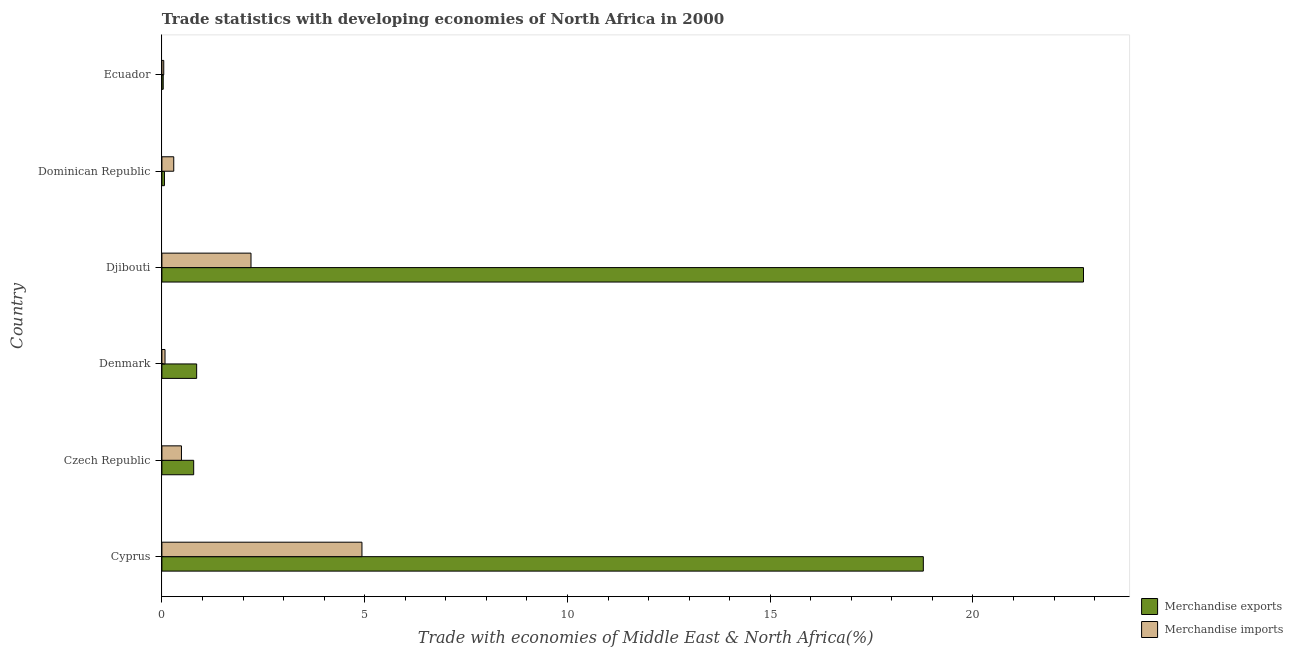How many different coloured bars are there?
Your answer should be compact. 2. How many groups of bars are there?
Provide a short and direct response. 6. How many bars are there on the 4th tick from the top?
Ensure brevity in your answer.  2. What is the label of the 5th group of bars from the top?
Offer a terse response. Czech Republic. What is the merchandise imports in Djibouti?
Give a very brief answer. 2.2. Across all countries, what is the maximum merchandise imports?
Your answer should be very brief. 4.93. Across all countries, what is the minimum merchandise imports?
Your answer should be compact. 0.05. In which country was the merchandise imports maximum?
Provide a succinct answer. Cyprus. In which country was the merchandise exports minimum?
Your response must be concise. Ecuador. What is the total merchandise imports in the graph?
Your answer should be compact. 8.03. What is the difference between the merchandise imports in Czech Republic and that in Dominican Republic?
Provide a succinct answer. 0.19. What is the difference between the merchandise imports in Cyprus and the merchandise exports in Djibouti?
Your answer should be very brief. -17.79. What is the average merchandise exports per country?
Keep it short and to the point. 7.21. What is the difference between the merchandise exports and merchandise imports in Dominican Republic?
Your answer should be compact. -0.23. In how many countries, is the merchandise imports greater than 13 %?
Offer a terse response. 0. What is the ratio of the merchandise imports in Djibouti to that in Dominican Republic?
Provide a succinct answer. 7.52. Is the merchandise exports in Denmark less than that in Djibouti?
Your answer should be compact. Yes. Is the difference between the merchandise exports in Czech Republic and Dominican Republic greater than the difference between the merchandise imports in Czech Republic and Dominican Republic?
Make the answer very short. Yes. What is the difference between the highest and the second highest merchandise exports?
Offer a terse response. 3.95. What is the difference between the highest and the lowest merchandise imports?
Give a very brief answer. 4.89. What does the 2nd bar from the bottom in Denmark represents?
Offer a very short reply. Merchandise imports. How many countries are there in the graph?
Your answer should be compact. 6. Are the values on the major ticks of X-axis written in scientific E-notation?
Offer a very short reply. No. How are the legend labels stacked?
Give a very brief answer. Vertical. What is the title of the graph?
Offer a very short reply. Trade statistics with developing economies of North Africa in 2000. What is the label or title of the X-axis?
Ensure brevity in your answer.  Trade with economies of Middle East & North Africa(%). What is the Trade with economies of Middle East & North Africa(%) of Merchandise exports in Cyprus?
Your answer should be compact. 18.78. What is the Trade with economies of Middle East & North Africa(%) in Merchandise imports in Cyprus?
Give a very brief answer. 4.93. What is the Trade with economies of Middle East & North Africa(%) of Merchandise exports in Czech Republic?
Ensure brevity in your answer.  0.78. What is the Trade with economies of Middle East & North Africa(%) in Merchandise imports in Czech Republic?
Your answer should be very brief. 0.48. What is the Trade with economies of Middle East & North Africa(%) of Merchandise exports in Denmark?
Keep it short and to the point. 0.86. What is the Trade with economies of Middle East & North Africa(%) of Merchandise imports in Denmark?
Provide a succinct answer. 0.08. What is the Trade with economies of Middle East & North Africa(%) of Merchandise exports in Djibouti?
Your answer should be very brief. 22.73. What is the Trade with economies of Middle East & North Africa(%) in Merchandise imports in Djibouti?
Offer a very short reply. 2.2. What is the Trade with economies of Middle East & North Africa(%) in Merchandise exports in Dominican Republic?
Ensure brevity in your answer.  0.06. What is the Trade with economies of Middle East & North Africa(%) in Merchandise imports in Dominican Republic?
Ensure brevity in your answer.  0.29. What is the Trade with economies of Middle East & North Africa(%) in Merchandise exports in Ecuador?
Give a very brief answer. 0.03. What is the Trade with economies of Middle East & North Africa(%) in Merchandise imports in Ecuador?
Provide a succinct answer. 0.05. Across all countries, what is the maximum Trade with economies of Middle East & North Africa(%) of Merchandise exports?
Your answer should be compact. 22.73. Across all countries, what is the maximum Trade with economies of Middle East & North Africa(%) in Merchandise imports?
Your answer should be compact. 4.93. Across all countries, what is the minimum Trade with economies of Middle East & North Africa(%) of Merchandise exports?
Offer a terse response. 0.03. Across all countries, what is the minimum Trade with economies of Middle East & North Africa(%) of Merchandise imports?
Provide a succinct answer. 0.05. What is the total Trade with economies of Middle East & North Africa(%) of Merchandise exports in the graph?
Offer a terse response. 43.24. What is the total Trade with economies of Middle East & North Africa(%) of Merchandise imports in the graph?
Your answer should be very brief. 8.03. What is the difference between the Trade with economies of Middle East & North Africa(%) of Merchandise exports in Cyprus and that in Czech Republic?
Your answer should be very brief. 17.99. What is the difference between the Trade with economies of Middle East & North Africa(%) in Merchandise imports in Cyprus and that in Czech Republic?
Your answer should be very brief. 4.45. What is the difference between the Trade with economies of Middle East & North Africa(%) of Merchandise exports in Cyprus and that in Denmark?
Keep it short and to the point. 17.92. What is the difference between the Trade with economies of Middle East & North Africa(%) in Merchandise imports in Cyprus and that in Denmark?
Provide a short and direct response. 4.86. What is the difference between the Trade with economies of Middle East & North Africa(%) of Merchandise exports in Cyprus and that in Djibouti?
Your answer should be compact. -3.95. What is the difference between the Trade with economies of Middle East & North Africa(%) in Merchandise imports in Cyprus and that in Djibouti?
Provide a short and direct response. 2.74. What is the difference between the Trade with economies of Middle East & North Africa(%) of Merchandise exports in Cyprus and that in Dominican Republic?
Keep it short and to the point. 18.71. What is the difference between the Trade with economies of Middle East & North Africa(%) in Merchandise imports in Cyprus and that in Dominican Republic?
Give a very brief answer. 4.64. What is the difference between the Trade with economies of Middle East & North Africa(%) of Merchandise exports in Cyprus and that in Ecuador?
Offer a very short reply. 18.74. What is the difference between the Trade with economies of Middle East & North Africa(%) in Merchandise imports in Cyprus and that in Ecuador?
Provide a short and direct response. 4.89. What is the difference between the Trade with economies of Middle East & North Africa(%) of Merchandise exports in Czech Republic and that in Denmark?
Provide a succinct answer. -0.07. What is the difference between the Trade with economies of Middle East & North Africa(%) of Merchandise imports in Czech Republic and that in Denmark?
Your response must be concise. 0.41. What is the difference between the Trade with economies of Middle East & North Africa(%) in Merchandise exports in Czech Republic and that in Djibouti?
Your answer should be compact. -21.94. What is the difference between the Trade with economies of Middle East & North Africa(%) of Merchandise imports in Czech Republic and that in Djibouti?
Your response must be concise. -1.71. What is the difference between the Trade with economies of Middle East & North Africa(%) in Merchandise exports in Czech Republic and that in Dominican Republic?
Provide a succinct answer. 0.72. What is the difference between the Trade with economies of Middle East & North Africa(%) in Merchandise imports in Czech Republic and that in Dominican Republic?
Your response must be concise. 0.19. What is the difference between the Trade with economies of Middle East & North Africa(%) of Merchandise exports in Czech Republic and that in Ecuador?
Provide a short and direct response. 0.75. What is the difference between the Trade with economies of Middle East & North Africa(%) of Merchandise imports in Czech Republic and that in Ecuador?
Provide a succinct answer. 0.44. What is the difference between the Trade with economies of Middle East & North Africa(%) in Merchandise exports in Denmark and that in Djibouti?
Offer a terse response. -21.87. What is the difference between the Trade with economies of Middle East & North Africa(%) in Merchandise imports in Denmark and that in Djibouti?
Provide a short and direct response. -2.12. What is the difference between the Trade with economies of Middle East & North Africa(%) of Merchandise exports in Denmark and that in Dominican Republic?
Provide a short and direct response. 0.79. What is the difference between the Trade with economies of Middle East & North Africa(%) in Merchandise imports in Denmark and that in Dominican Republic?
Your answer should be compact. -0.22. What is the difference between the Trade with economies of Middle East & North Africa(%) in Merchandise exports in Denmark and that in Ecuador?
Ensure brevity in your answer.  0.82. What is the difference between the Trade with economies of Middle East & North Africa(%) of Merchandise imports in Denmark and that in Ecuador?
Offer a very short reply. 0.03. What is the difference between the Trade with economies of Middle East & North Africa(%) of Merchandise exports in Djibouti and that in Dominican Republic?
Ensure brevity in your answer.  22.66. What is the difference between the Trade with economies of Middle East & North Africa(%) of Merchandise imports in Djibouti and that in Dominican Republic?
Provide a short and direct response. 1.9. What is the difference between the Trade with economies of Middle East & North Africa(%) in Merchandise exports in Djibouti and that in Ecuador?
Provide a succinct answer. 22.69. What is the difference between the Trade with economies of Middle East & North Africa(%) of Merchandise imports in Djibouti and that in Ecuador?
Provide a short and direct response. 2.15. What is the difference between the Trade with economies of Middle East & North Africa(%) in Merchandise exports in Dominican Republic and that in Ecuador?
Offer a terse response. 0.03. What is the difference between the Trade with economies of Middle East & North Africa(%) of Merchandise imports in Dominican Republic and that in Ecuador?
Keep it short and to the point. 0.25. What is the difference between the Trade with economies of Middle East & North Africa(%) in Merchandise exports in Cyprus and the Trade with economies of Middle East & North Africa(%) in Merchandise imports in Czech Republic?
Your answer should be very brief. 18.29. What is the difference between the Trade with economies of Middle East & North Africa(%) in Merchandise exports in Cyprus and the Trade with economies of Middle East & North Africa(%) in Merchandise imports in Denmark?
Provide a succinct answer. 18.7. What is the difference between the Trade with economies of Middle East & North Africa(%) of Merchandise exports in Cyprus and the Trade with economies of Middle East & North Africa(%) of Merchandise imports in Djibouti?
Your response must be concise. 16.58. What is the difference between the Trade with economies of Middle East & North Africa(%) in Merchandise exports in Cyprus and the Trade with economies of Middle East & North Africa(%) in Merchandise imports in Dominican Republic?
Keep it short and to the point. 18.48. What is the difference between the Trade with economies of Middle East & North Africa(%) of Merchandise exports in Cyprus and the Trade with economies of Middle East & North Africa(%) of Merchandise imports in Ecuador?
Your answer should be very brief. 18.73. What is the difference between the Trade with economies of Middle East & North Africa(%) in Merchandise exports in Czech Republic and the Trade with economies of Middle East & North Africa(%) in Merchandise imports in Denmark?
Make the answer very short. 0.71. What is the difference between the Trade with economies of Middle East & North Africa(%) in Merchandise exports in Czech Republic and the Trade with economies of Middle East & North Africa(%) in Merchandise imports in Djibouti?
Provide a short and direct response. -1.41. What is the difference between the Trade with economies of Middle East & North Africa(%) in Merchandise exports in Czech Republic and the Trade with economies of Middle East & North Africa(%) in Merchandise imports in Dominican Republic?
Give a very brief answer. 0.49. What is the difference between the Trade with economies of Middle East & North Africa(%) in Merchandise exports in Czech Republic and the Trade with economies of Middle East & North Africa(%) in Merchandise imports in Ecuador?
Offer a terse response. 0.74. What is the difference between the Trade with economies of Middle East & North Africa(%) in Merchandise exports in Denmark and the Trade with economies of Middle East & North Africa(%) in Merchandise imports in Djibouti?
Your response must be concise. -1.34. What is the difference between the Trade with economies of Middle East & North Africa(%) in Merchandise exports in Denmark and the Trade with economies of Middle East & North Africa(%) in Merchandise imports in Dominican Republic?
Your answer should be very brief. 0.57. What is the difference between the Trade with economies of Middle East & North Africa(%) in Merchandise exports in Denmark and the Trade with economies of Middle East & North Africa(%) in Merchandise imports in Ecuador?
Offer a very short reply. 0.81. What is the difference between the Trade with economies of Middle East & North Africa(%) of Merchandise exports in Djibouti and the Trade with economies of Middle East & North Africa(%) of Merchandise imports in Dominican Republic?
Offer a very short reply. 22.43. What is the difference between the Trade with economies of Middle East & North Africa(%) in Merchandise exports in Djibouti and the Trade with economies of Middle East & North Africa(%) in Merchandise imports in Ecuador?
Keep it short and to the point. 22.68. What is the difference between the Trade with economies of Middle East & North Africa(%) in Merchandise exports in Dominican Republic and the Trade with economies of Middle East & North Africa(%) in Merchandise imports in Ecuador?
Offer a very short reply. 0.02. What is the average Trade with economies of Middle East & North Africa(%) in Merchandise exports per country?
Provide a succinct answer. 7.21. What is the average Trade with economies of Middle East & North Africa(%) of Merchandise imports per country?
Make the answer very short. 1.34. What is the difference between the Trade with economies of Middle East & North Africa(%) of Merchandise exports and Trade with economies of Middle East & North Africa(%) of Merchandise imports in Cyprus?
Ensure brevity in your answer.  13.84. What is the difference between the Trade with economies of Middle East & North Africa(%) of Merchandise exports and Trade with economies of Middle East & North Africa(%) of Merchandise imports in Czech Republic?
Provide a short and direct response. 0.3. What is the difference between the Trade with economies of Middle East & North Africa(%) in Merchandise exports and Trade with economies of Middle East & North Africa(%) in Merchandise imports in Denmark?
Your answer should be very brief. 0.78. What is the difference between the Trade with economies of Middle East & North Africa(%) of Merchandise exports and Trade with economies of Middle East & North Africa(%) of Merchandise imports in Djibouti?
Your answer should be very brief. 20.53. What is the difference between the Trade with economies of Middle East & North Africa(%) in Merchandise exports and Trade with economies of Middle East & North Africa(%) in Merchandise imports in Dominican Republic?
Offer a very short reply. -0.23. What is the difference between the Trade with economies of Middle East & North Africa(%) of Merchandise exports and Trade with economies of Middle East & North Africa(%) of Merchandise imports in Ecuador?
Your answer should be very brief. -0.01. What is the ratio of the Trade with economies of Middle East & North Africa(%) in Merchandise exports in Cyprus to that in Czech Republic?
Offer a terse response. 23.96. What is the ratio of the Trade with economies of Middle East & North Africa(%) in Merchandise imports in Cyprus to that in Czech Republic?
Give a very brief answer. 10.23. What is the ratio of the Trade with economies of Middle East & North Africa(%) of Merchandise exports in Cyprus to that in Denmark?
Offer a terse response. 21.9. What is the ratio of the Trade with economies of Middle East & North Africa(%) in Merchandise imports in Cyprus to that in Denmark?
Ensure brevity in your answer.  64.27. What is the ratio of the Trade with economies of Middle East & North Africa(%) of Merchandise exports in Cyprus to that in Djibouti?
Offer a very short reply. 0.83. What is the ratio of the Trade with economies of Middle East & North Africa(%) of Merchandise imports in Cyprus to that in Djibouti?
Keep it short and to the point. 2.25. What is the ratio of the Trade with economies of Middle East & North Africa(%) of Merchandise exports in Cyprus to that in Dominican Republic?
Offer a terse response. 298.05. What is the ratio of the Trade with economies of Middle East & North Africa(%) in Merchandise imports in Cyprus to that in Dominican Republic?
Keep it short and to the point. 16.89. What is the ratio of the Trade with economies of Middle East & North Africa(%) in Merchandise exports in Cyprus to that in Ecuador?
Your response must be concise. 580.75. What is the ratio of the Trade with economies of Middle East & North Africa(%) in Merchandise imports in Cyprus to that in Ecuador?
Make the answer very short. 107.77. What is the ratio of the Trade with economies of Middle East & North Africa(%) of Merchandise exports in Czech Republic to that in Denmark?
Your response must be concise. 0.91. What is the ratio of the Trade with economies of Middle East & North Africa(%) of Merchandise imports in Czech Republic to that in Denmark?
Give a very brief answer. 6.28. What is the ratio of the Trade with economies of Middle East & North Africa(%) in Merchandise exports in Czech Republic to that in Djibouti?
Your response must be concise. 0.03. What is the ratio of the Trade with economies of Middle East & North Africa(%) of Merchandise imports in Czech Republic to that in Djibouti?
Offer a terse response. 0.22. What is the ratio of the Trade with economies of Middle East & North Africa(%) in Merchandise exports in Czech Republic to that in Dominican Republic?
Your answer should be very brief. 12.44. What is the ratio of the Trade with economies of Middle East & North Africa(%) of Merchandise imports in Czech Republic to that in Dominican Republic?
Make the answer very short. 1.65. What is the ratio of the Trade with economies of Middle East & North Africa(%) in Merchandise exports in Czech Republic to that in Ecuador?
Your answer should be very brief. 24.24. What is the ratio of the Trade with economies of Middle East & North Africa(%) of Merchandise imports in Czech Republic to that in Ecuador?
Offer a terse response. 10.54. What is the ratio of the Trade with economies of Middle East & North Africa(%) of Merchandise exports in Denmark to that in Djibouti?
Ensure brevity in your answer.  0.04. What is the ratio of the Trade with economies of Middle East & North Africa(%) in Merchandise imports in Denmark to that in Djibouti?
Keep it short and to the point. 0.03. What is the ratio of the Trade with economies of Middle East & North Africa(%) of Merchandise exports in Denmark to that in Dominican Republic?
Your answer should be compact. 13.61. What is the ratio of the Trade with economies of Middle East & North Africa(%) in Merchandise imports in Denmark to that in Dominican Republic?
Give a very brief answer. 0.26. What is the ratio of the Trade with economies of Middle East & North Africa(%) of Merchandise exports in Denmark to that in Ecuador?
Make the answer very short. 26.51. What is the ratio of the Trade with economies of Middle East & North Africa(%) in Merchandise imports in Denmark to that in Ecuador?
Offer a very short reply. 1.68. What is the ratio of the Trade with economies of Middle East & North Africa(%) of Merchandise exports in Djibouti to that in Dominican Republic?
Make the answer very short. 360.75. What is the ratio of the Trade with economies of Middle East & North Africa(%) in Merchandise imports in Djibouti to that in Dominican Republic?
Your response must be concise. 7.52. What is the ratio of the Trade with economies of Middle East & North Africa(%) in Merchandise exports in Djibouti to that in Ecuador?
Offer a terse response. 702.92. What is the ratio of the Trade with economies of Middle East & North Africa(%) of Merchandise imports in Djibouti to that in Ecuador?
Offer a terse response. 47.99. What is the ratio of the Trade with economies of Middle East & North Africa(%) in Merchandise exports in Dominican Republic to that in Ecuador?
Your answer should be compact. 1.95. What is the ratio of the Trade with economies of Middle East & North Africa(%) of Merchandise imports in Dominican Republic to that in Ecuador?
Provide a short and direct response. 6.38. What is the difference between the highest and the second highest Trade with economies of Middle East & North Africa(%) in Merchandise exports?
Make the answer very short. 3.95. What is the difference between the highest and the second highest Trade with economies of Middle East & North Africa(%) of Merchandise imports?
Offer a very short reply. 2.74. What is the difference between the highest and the lowest Trade with economies of Middle East & North Africa(%) in Merchandise exports?
Keep it short and to the point. 22.69. What is the difference between the highest and the lowest Trade with economies of Middle East & North Africa(%) of Merchandise imports?
Your answer should be very brief. 4.89. 